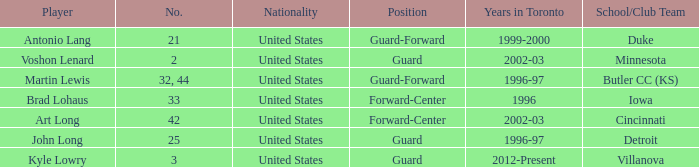What player played guard for toronto in 1996-97? John Long. 